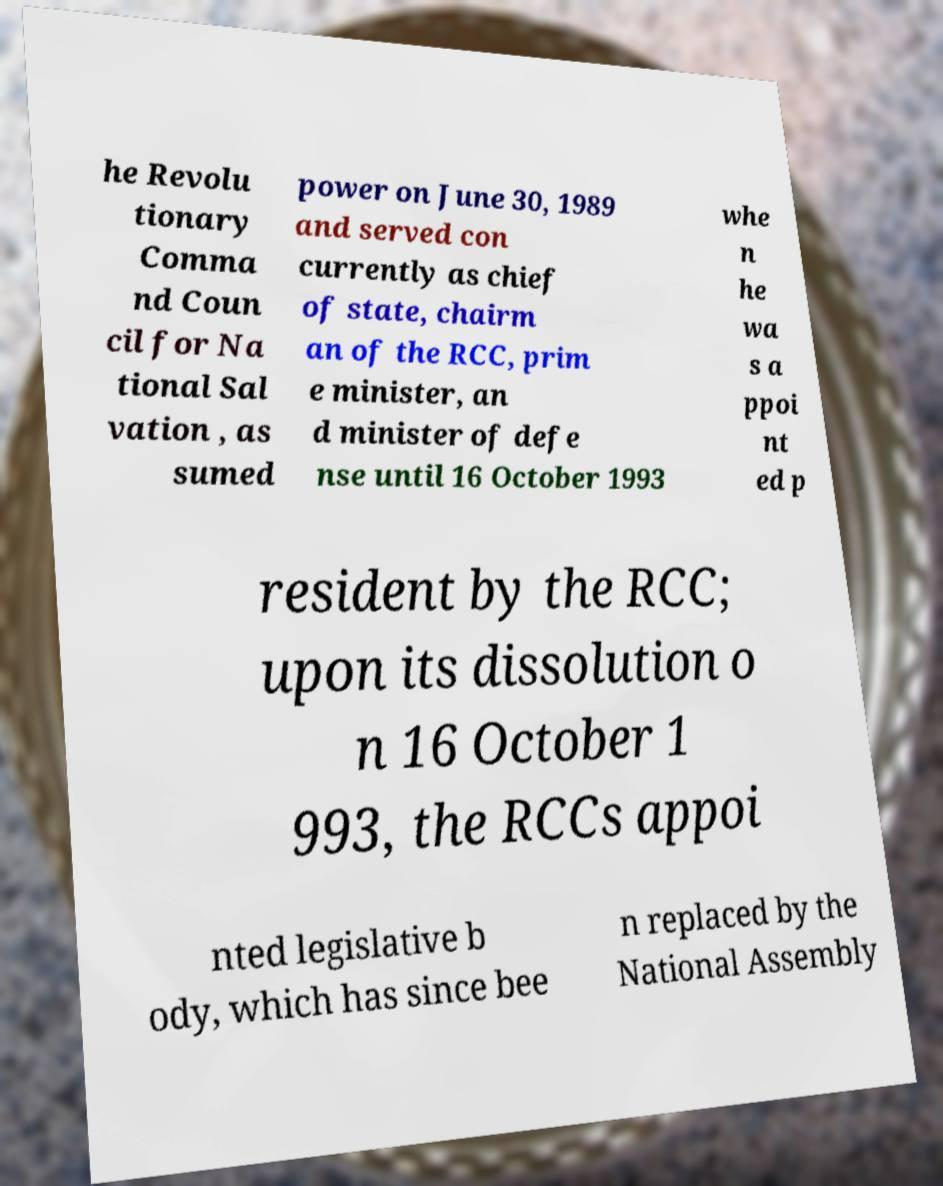Can you accurately transcribe the text from the provided image for me? he Revolu tionary Comma nd Coun cil for Na tional Sal vation , as sumed power on June 30, 1989 and served con currently as chief of state, chairm an of the RCC, prim e minister, an d minister of defe nse until 16 October 1993 whe n he wa s a ppoi nt ed p resident by the RCC; upon its dissolution o n 16 October 1 993, the RCCs appoi nted legislative b ody, which has since bee n replaced by the National Assembly 